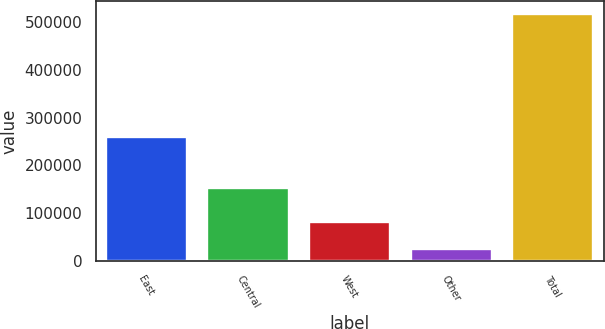Convert chart to OTSL. <chart><loc_0><loc_0><loc_500><loc_500><bar_chart><fcel>East<fcel>Central<fcel>West<fcel>Other<fcel>Total<nl><fcel>258594<fcel>153173<fcel>80617<fcel>25679<fcel>518063<nl></chart> 